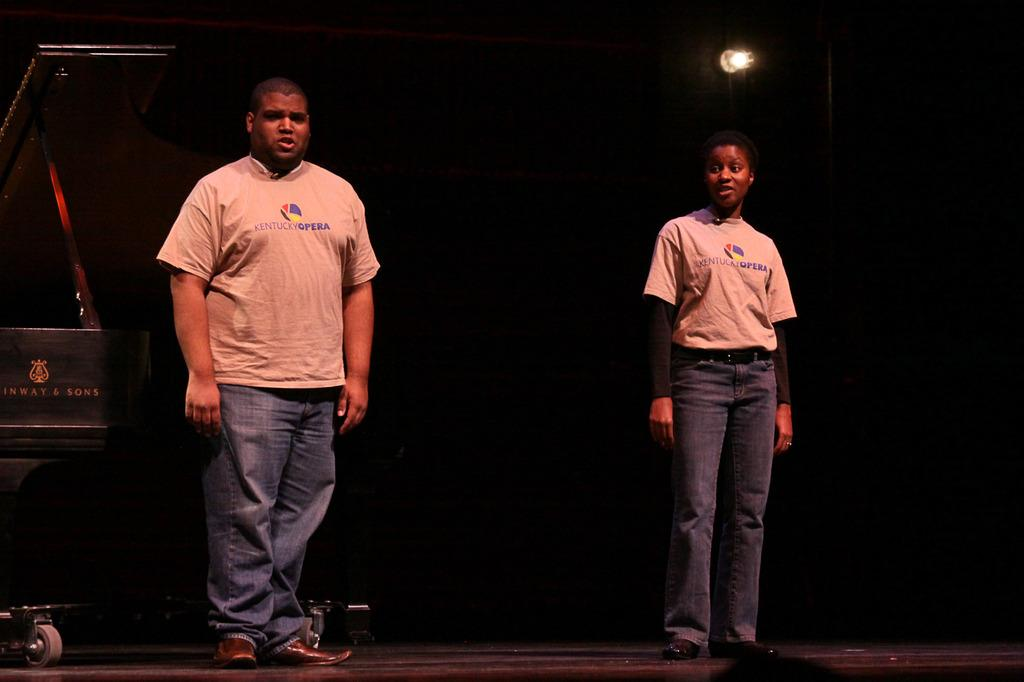Who are the people in the image? There is a man and a woman in the image. Where are the man and the woman located in the image? Both the man and the woman are standing on a stage. What type of sea creature can be seen swimming on the stage in the image? There is no sea creature present in the image; it features a man and a woman standing on a stage. 